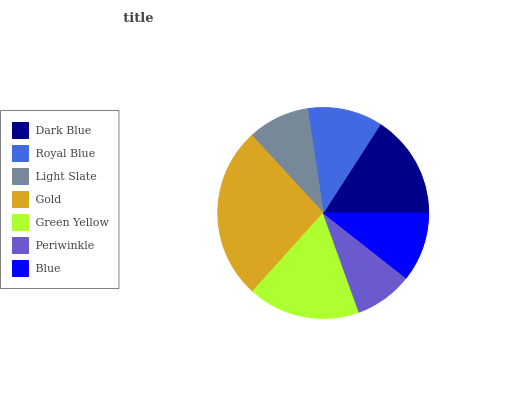Is Periwinkle the minimum?
Answer yes or no. Yes. Is Gold the maximum?
Answer yes or no. Yes. Is Royal Blue the minimum?
Answer yes or no. No. Is Royal Blue the maximum?
Answer yes or no. No. Is Dark Blue greater than Royal Blue?
Answer yes or no. Yes. Is Royal Blue less than Dark Blue?
Answer yes or no. Yes. Is Royal Blue greater than Dark Blue?
Answer yes or no. No. Is Dark Blue less than Royal Blue?
Answer yes or no. No. Is Royal Blue the high median?
Answer yes or no. Yes. Is Royal Blue the low median?
Answer yes or no. Yes. Is Light Slate the high median?
Answer yes or no. No. Is Dark Blue the low median?
Answer yes or no. No. 